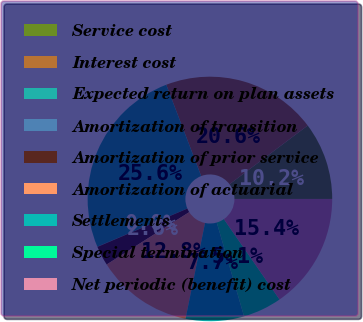<chart> <loc_0><loc_0><loc_500><loc_500><pie_chart><fcel>Service cost<fcel>Interest cost<fcel>Expected return on plan assets<fcel>Amortization of transition<fcel>Amortization of prior service<fcel>Amortization of actuarial<fcel>Settlements<fcel>Special termination<fcel>Net periodic (benefit) cost<nl><fcel>10.25%<fcel>20.56%<fcel>25.57%<fcel>0.03%<fcel>2.59%<fcel>12.8%<fcel>7.7%<fcel>5.14%<fcel>15.36%<nl></chart> 